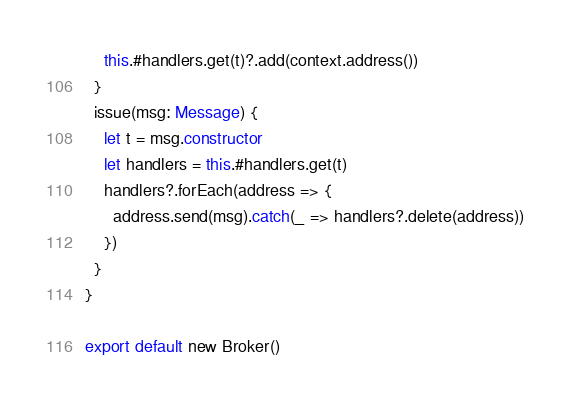Convert code to text. <code><loc_0><loc_0><loc_500><loc_500><_TypeScript_>    this.#handlers.get(t)?.add(context.address())
  }
  issue(msg: Message) {
    let t = msg.constructor
    let handlers = this.#handlers.get(t)
    handlers?.forEach(address => {
      address.send(msg).catch(_ => handlers?.delete(address))
    })
  }
}

export default new Broker()</code> 